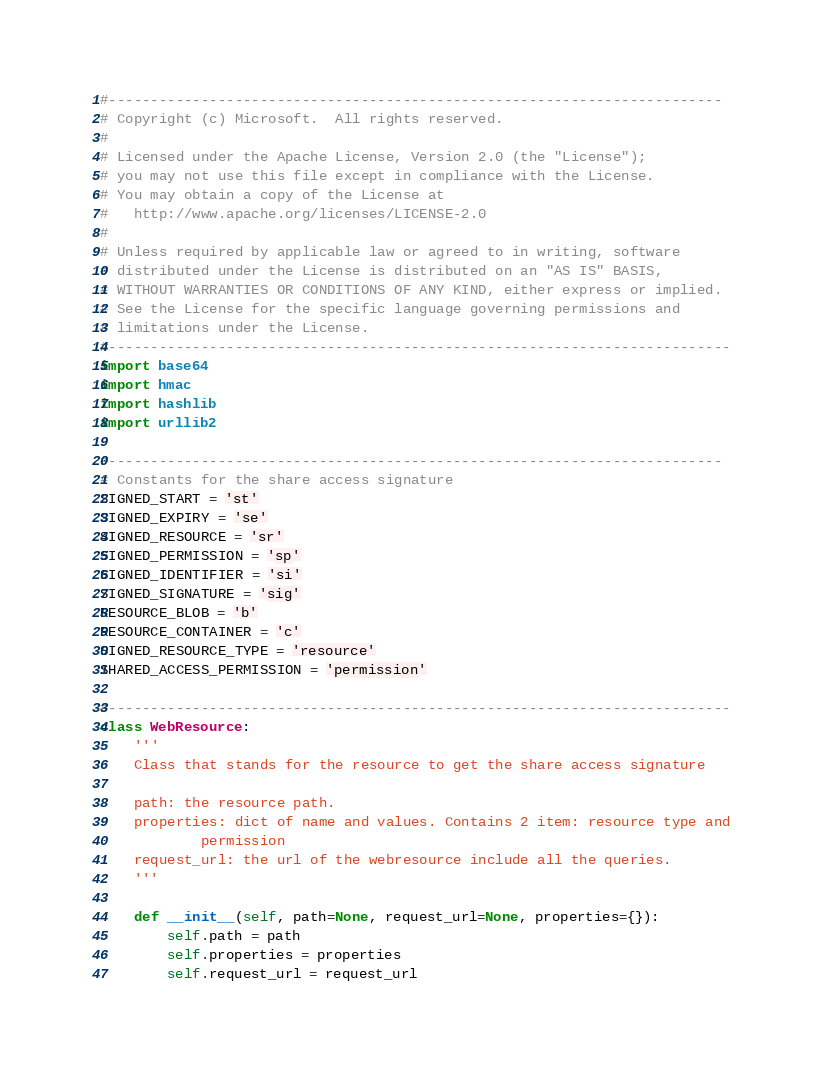<code> <loc_0><loc_0><loc_500><loc_500><_Python_>#-------------------------------------------------------------------------
# Copyright (c) Microsoft.  All rights reserved.
#
# Licensed under the Apache License, Version 2.0 (the "License");
# you may not use this file except in compliance with the License.
# You may obtain a copy of the License at
#   http://www.apache.org/licenses/LICENSE-2.0
#
# Unless required by applicable law or agreed to in writing, software
# distributed under the License is distributed on an "AS IS" BASIS,
# WITHOUT WARRANTIES OR CONDITIONS OF ANY KIND, either express or implied.
# See the License for the specific language governing permissions and
# limitations under the License.
#--------------------------------------------------------------------------
import base64
import hmac
import hashlib
import urllib2

#-------------------------------------------------------------------------
# Constants for the share access signature
SIGNED_START = 'st'
SIGNED_EXPIRY = 'se'
SIGNED_RESOURCE = 'sr'
SIGNED_PERMISSION = 'sp'
SIGNED_IDENTIFIER = 'si'
SIGNED_SIGNATURE = 'sig'
RESOURCE_BLOB = 'b'
RESOURCE_CONTAINER = 'c'
SIGNED_RESOURCE_TYPE = 'resource'
SHARED_ACCESS_PERMISSION = 'permission'

#--------------------------------------------------------------------------
class WebResource:
    ''' 
    Class that stands for the resource to get the share access signature

    path: the resource path.
    properties: dict of name and values. Contains 2 item: resource type and 
            permission
    request_url: the url of the webresource include all the queries.
    '''

    def __init__(self, path=None, request_url=None, properties={}):
        self.path = path
        self.properties = properties
        self.request_url = request_url
</code> 